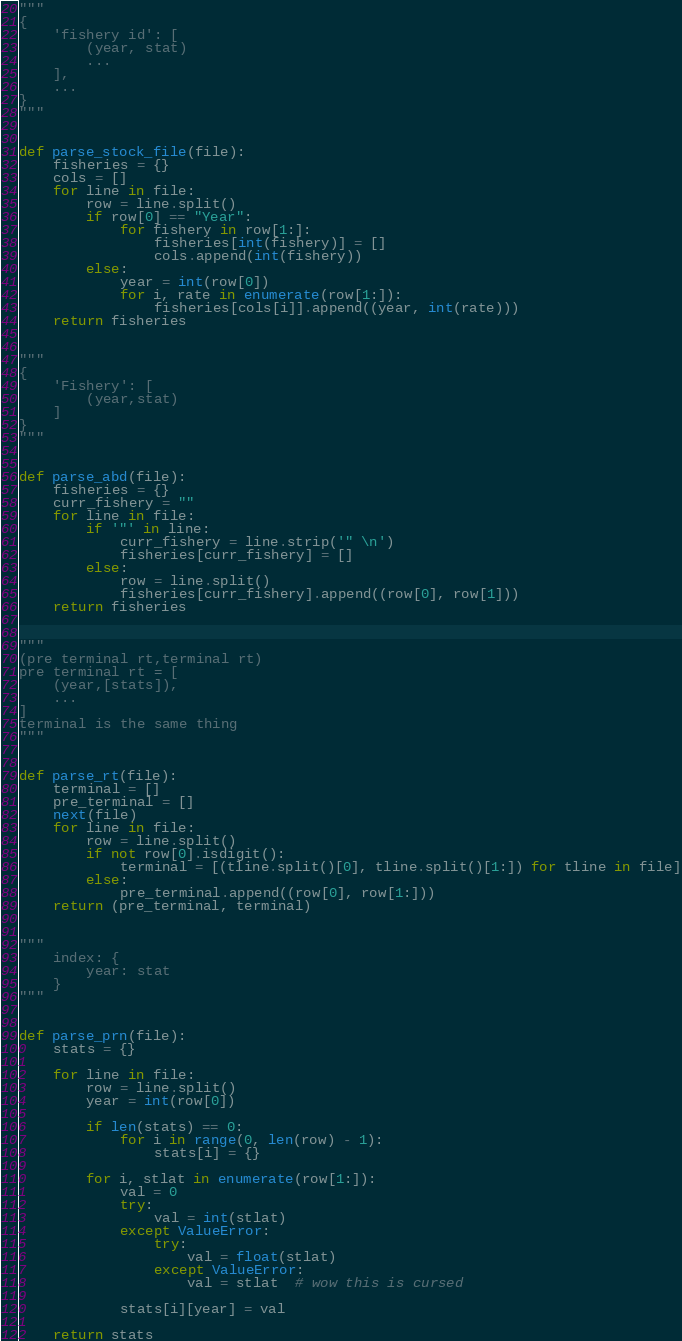<code> <loc_0><loc_0><loc_500><loc_500><_Python_>"""
{
    'fishery id': [
        (year, stat)
        ...
    ],
    ...
}
"""


def parse_stock_file(file):
    fisheries = {}
    cols = []
    for line in file:
        row = line.split()
        if row[0] == "Year":
            for fishery in row[1:]:
                fisheries[int(fishery)] = []
                cols.append(int(fishery))
        else:
            year = int(row[0])
            for i, rate in enumerate(row[1:]):
                fisheries[cols[i]].append((year, int(rate)))
    return fisheries


"""
{
    'Fishery': [
        (year,stat)
    ]
}
"""


def parse_abd(file):
    fisheries = {}
    curr_fishery = ""
    for line in file:
        if '"' in line:
            curr_fishery = line.strip('" \n')
            fisheries[curr_fishery] = []
        else:
            row = line.split()
            fisheries[curr_fishery].append((row[0], row[1]))
    return fisheries


"""
(pre terminal rt,terminal rt)
pre terminal rt = [
    (year,[stats]),
    ...
]
terminal is the same thing
"""


def parse_rt(file):
    terminal = []
    pre_terminal = []
    next(file)
    for line in file:
        row = line.split()
        if not row[0].isdigit():
            terminal = [(tline.split()[0], tline.split()[1:]) for tline in file]
        else:
            pre_terminal.append((row[0], row[1:]))
    return (pre_terminal, terminal)


"""
    index: {
        year: stat
    }
"""


def parse_prn(file):
    stats = {}

    for line in file:
        row = line.split()
        year = int(row[0])

        if len(stats) == 0:
            for i in range(0, len(row) - 1):
                stats[i] = {}

        for i, stlat in enumerate(row[1:]):
            val = 0
            try:
                val = int(stlat)
            except ValueError:
                try:
                    val = float(stlat)
                except ValueError:
                    val = stlat  # wow this is cursed

            stats[i][year] = val

    return stats
</code> 